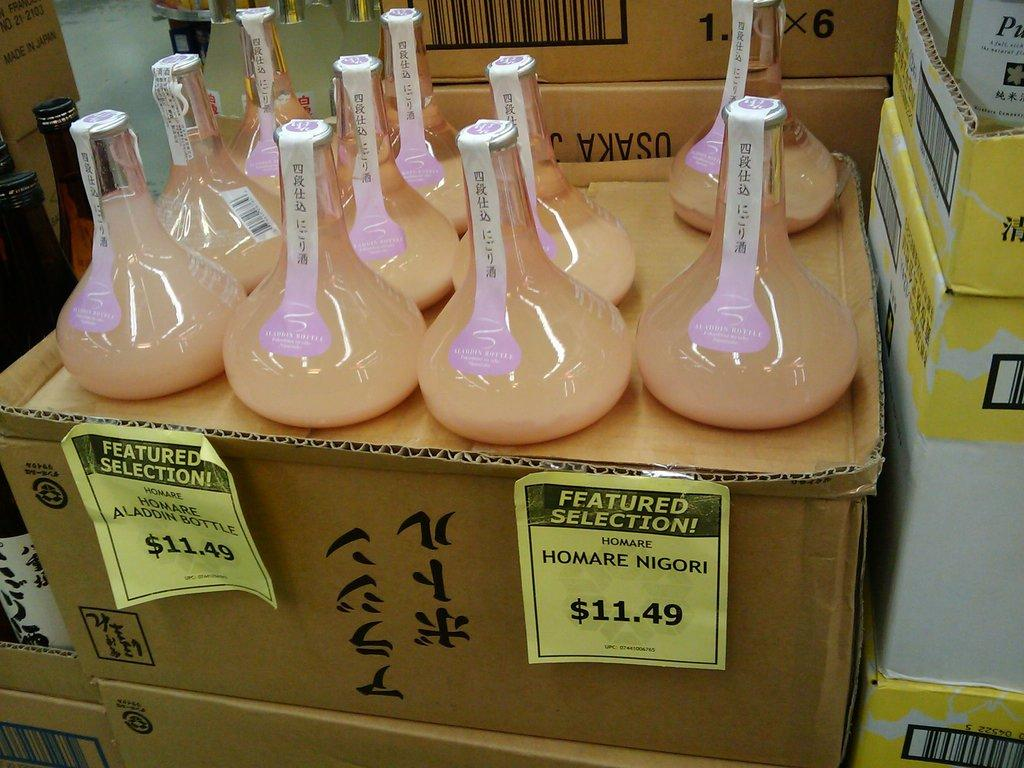What is the primary subject of the image? The primary subject of the image is many bottles. What is the surface on which the bottles are placed? The bottles are on a cardboard surface. What can be seen in the background of the image? There are cardboard boxes in the background of the image. How steep is the slope in the image? There is no slope present in the image; it features bottles on a cardboard surface and cardboard boxes in the background. 